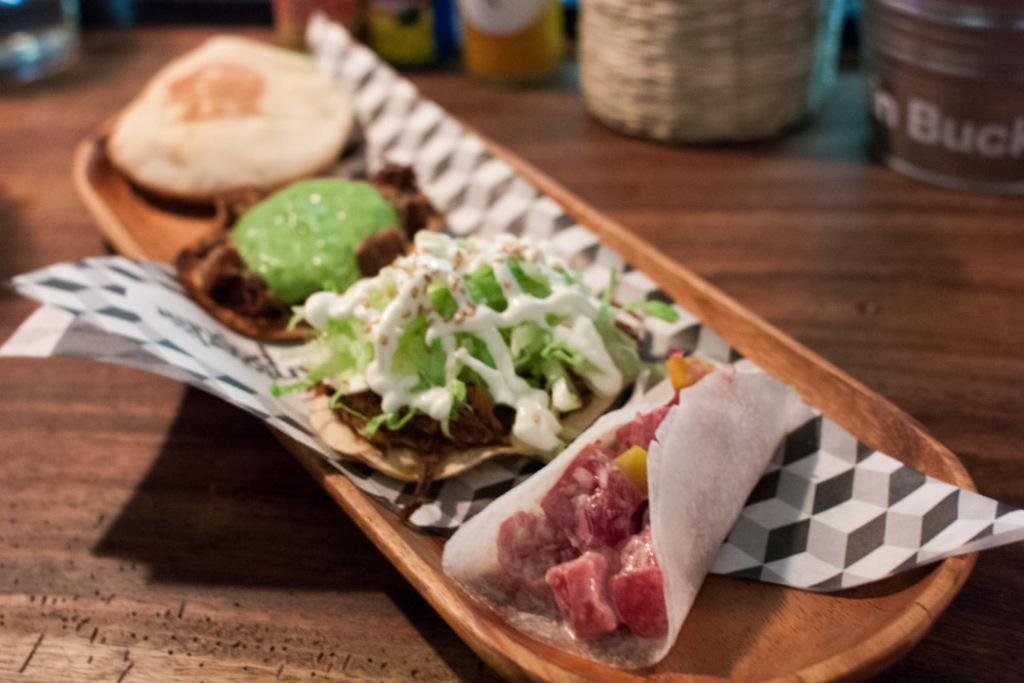What is placed on the wooden tray in the image? There are food items in a wooden tray in the image. What can be seen at the top of the image? There are containers at the top of the image. What is the color of the surface at the bottom of the image? The surface at the bottom of the image is brown. What action is the dad performing in the image? There is no dad present in the image, so it is not possible to answer that question. 